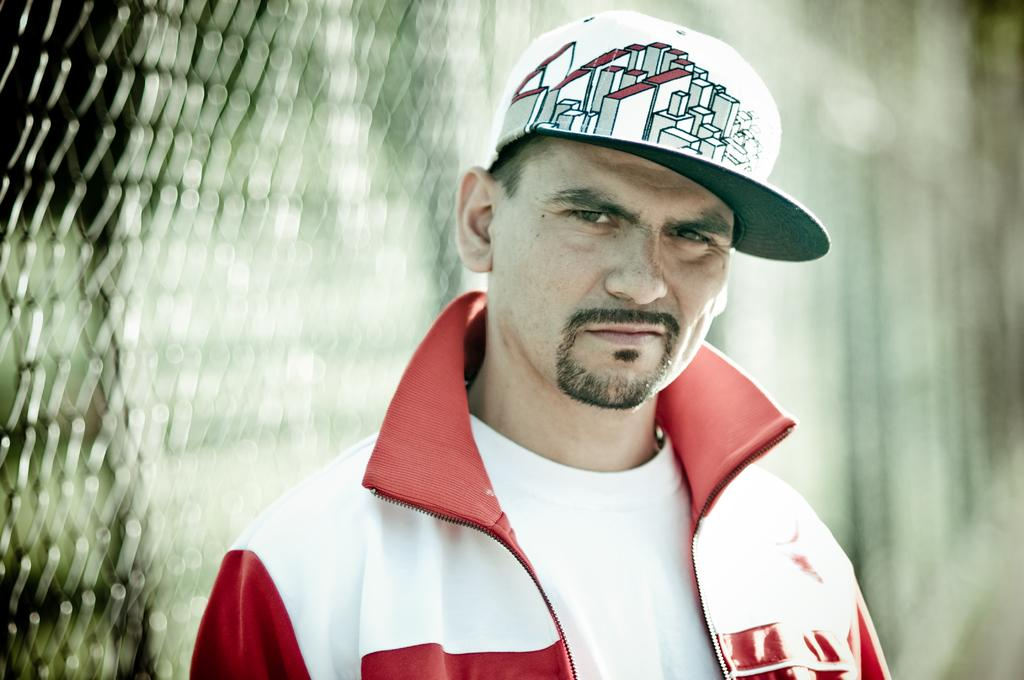What is the main subject of the image? There is a person standing in the image. What is the person wearing? The person is wearing a red and white color jacket and a white cap. Can you describe the background of the image? The background of the image is blurred. Where is the grandmother sitting with her bean in the image? There is no grandmother or bean present in the image. 